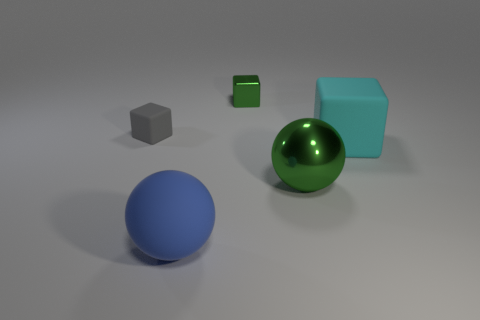Is there any other thing that has the same color as the small metallic object?
Give a very brief answer. Yes. Are there any other large things that have the same shape as the cyan rubber object?
Your answer should be very brief. No. The gray rubber thing that is the same size as the green shiny block is what shape?
Offer a terse response. Cube. There is a green object that is on the left side of the green thing that is right of the shiny thing behind the big cyan object; what is its material?
Your response must be concise. Metal. Do the cyan rubber thing and the metallic cube have the same size?
Give a very brief answer. No. What is the material of the big block?
Your answer should be compact. Rubber. There is a sphere that is the same color as the tiny metal object; what material is it?
Offer a very short reply. Metal. There is a metallic thing left of the big shiny sphere; is it the same shape as the large blue object?
Offer a very short reply. No. How many things are shiny balls or tiny purple metal cylinders?
Your answer should be very brief. 1. Does the green object that is in front of the big cyan thing have the same material as the green block?
Make the answer very short. Yes. 